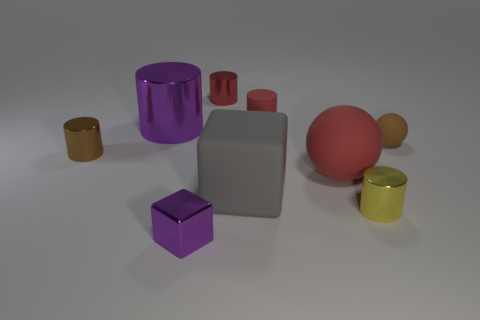Subtract all yellow shiny cylinders. How many cylinders are left? 4 Subtract all purple cylinders. How many cylinders are left? 4 Subtract all brown cylinders. Subtract all gray blocks. How many cylinders are left? 4 Subtract all cylinders. How many objects are left? 4 Subtract all large brown metallic cylinders. Subtract all tiny red rubber cylinders. How many objects are left? 8 Add 2 tiny cylinders. How many tiny cylinders are left? 6 Add 7 small blue rubber balls. How many small blue rubber balls exist? 7 Subtract 0 gray cylinders. How many objects are left? 9 